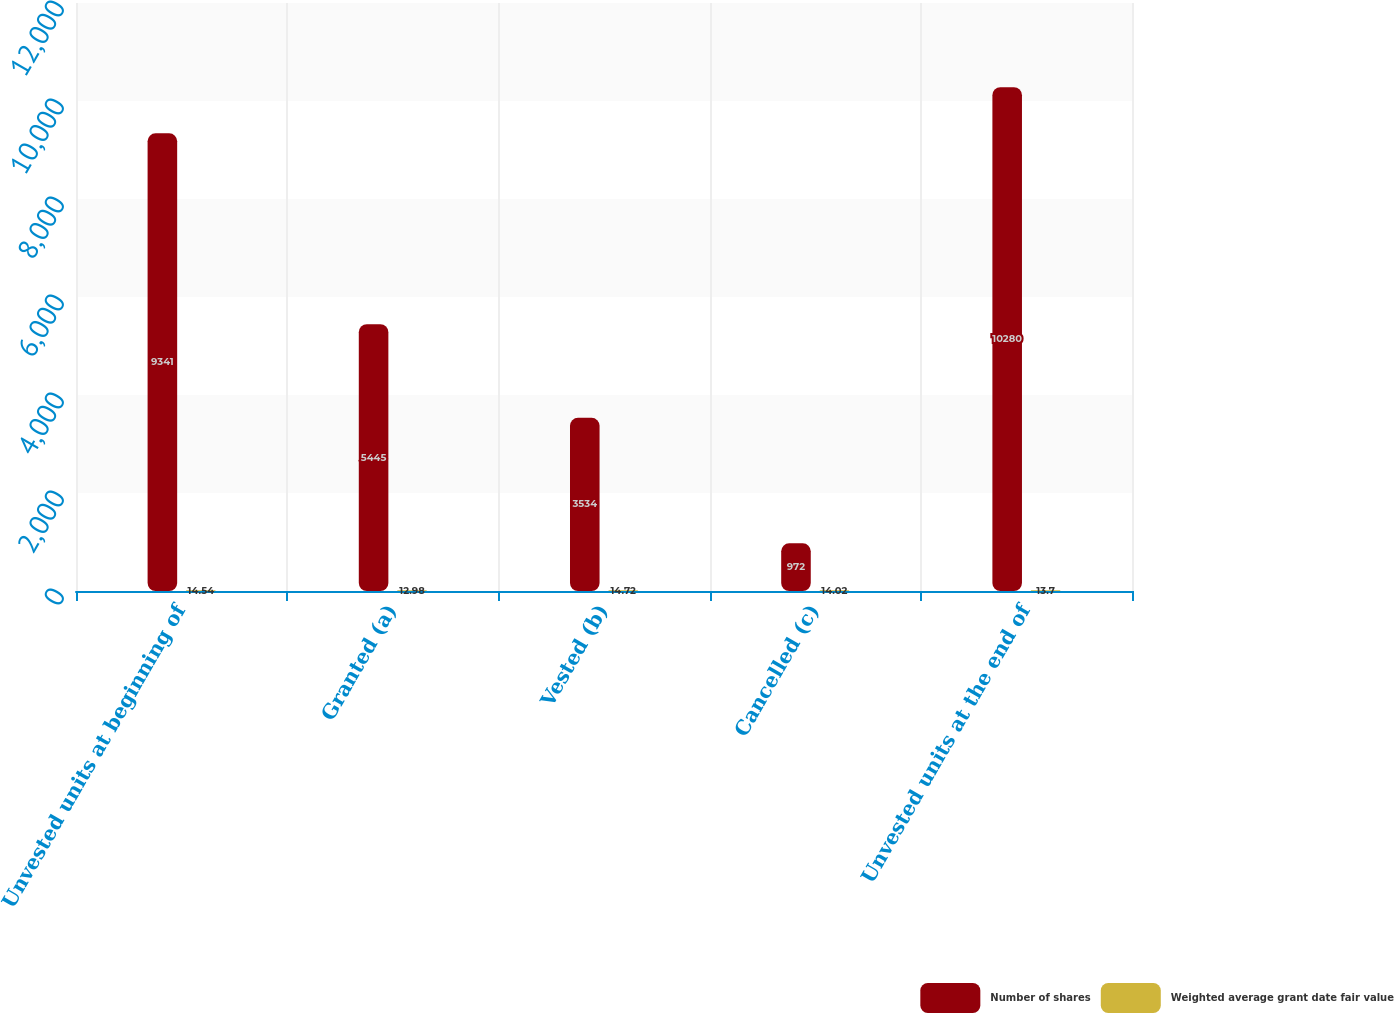Convert chart to OTSL. <chart><loc_0><loc_0><loc_500><loc_500><stacked_bar_chart><ecel><fcel>Unvested units at beginning of<fcel>Granted (a)<fcel>Vested (b)<fcel>Cancelled (c)<fcel>Unvested units at the end of<nl><fcel>Number of shares<fcel>9341<fcel>5445<fcel>3534<fcel>972<fcel>10280<nl><fcel>Weighted average grant date fair value<fcel>14.54<fcel>12.98<fcel>14.72<fcel>14.02<fcel>13.7<nl></chart> 